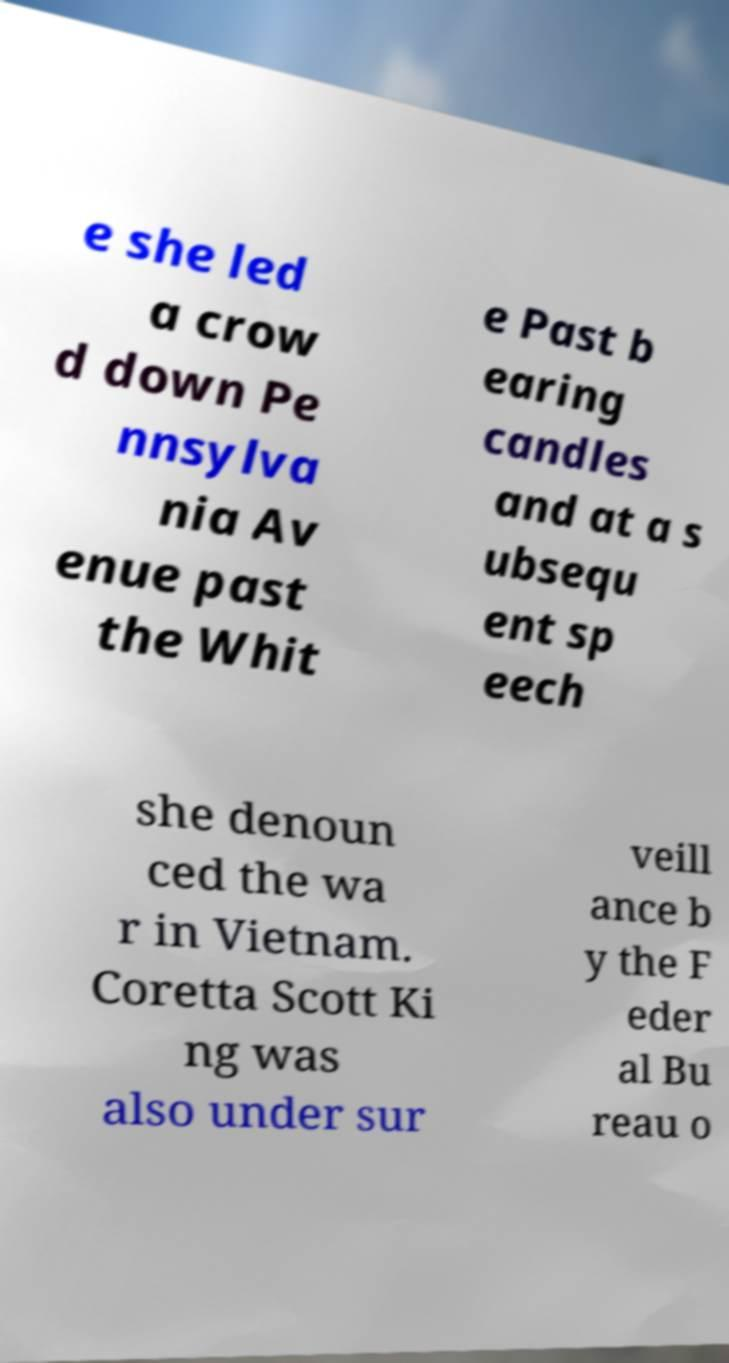Can you read and provide the text displayed in the image?This photo seems to have some interesting text. Can you extract and type it out for me? e she led a crow d down Pe nnsylva nia Av enue past the Whit e Past b earing candles and at a s ubsequ ent sp eech she denoun ced the wa r in Vietnam. Coretta Scott Ki ng was also under sur veill ance b y the F eder al Bu reau o 